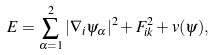<formula> <loc_0><loc_0><loc_500><loc_500>E = \sum _ { \alpha = 1 } ^ { 2 } | \nabla _ { i } \psi _ { \alpha } | ^ { 2 } + F _ { i k } ^ { 2 } + v ( \psi ) ,</formula> 